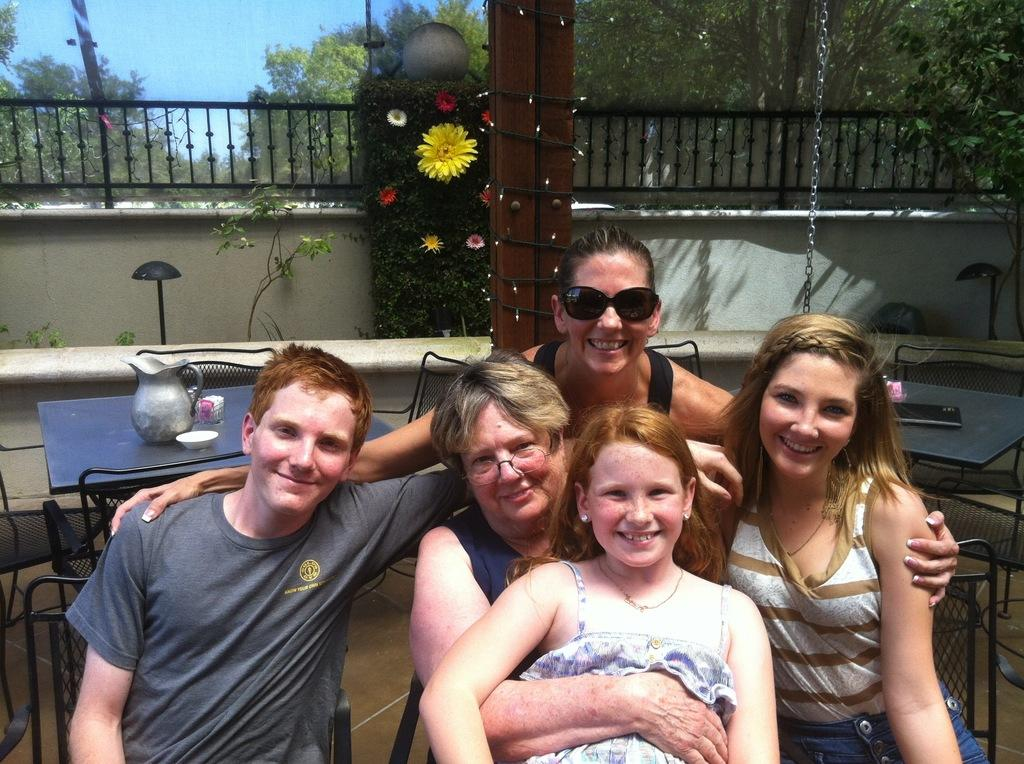What is the main subject of the image? The main subject of the image is a group of people. What are the people in the image doing? The people are sitting on chairs in the image. What can be seen in the background of the image? There is sky visible in the image, and there are many trees in the image. How many tables and chairs are present in the image? There are few tables and chairs in the image. What type of cup is being used for the dinner in the image? There is no dinner or cup present in the image. 